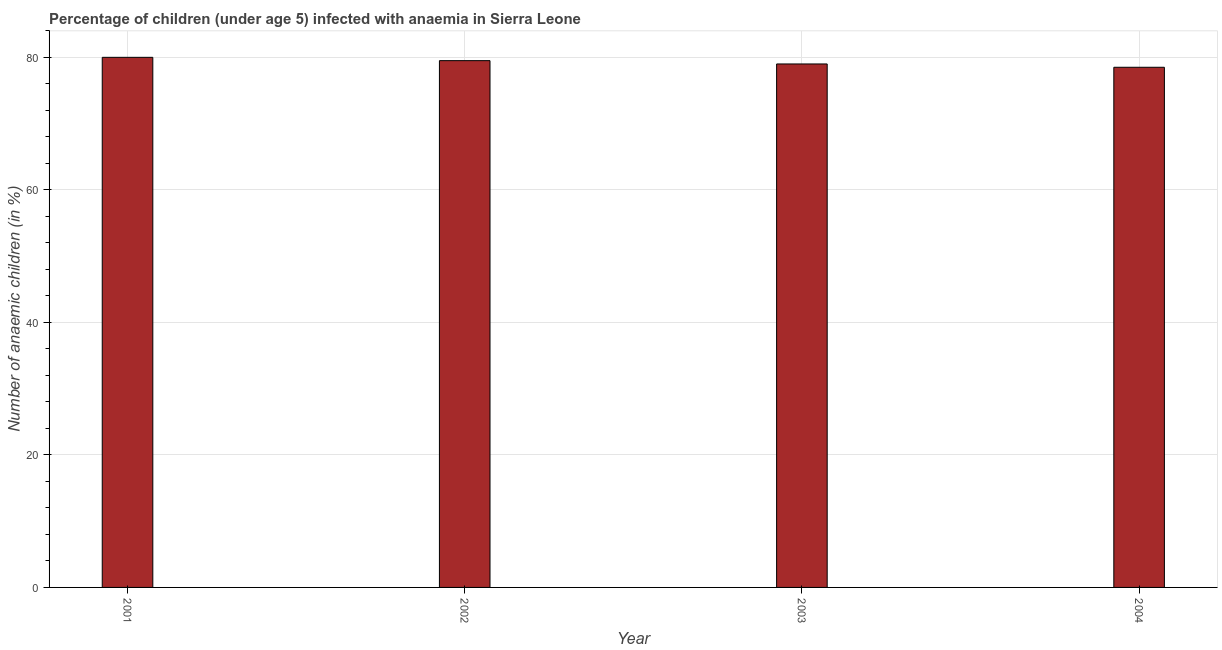What is the title of the graph?
Provide a short and direct response. Percentage of children (under age 5) infected with anaemia in Sierra Leone. What is the label or title of the Y-axis?
Make the answer very short. Number of anaemic children (in %). What is the number of anaemic children in 2002?
Your answer should be very brief. 79.5. Across all years, what is the minimum number of anaemic children?
Make the answer very short. 78.5. In which year was the number of anaemic children maximum?
Make the answer very short. 2001. In which year was the number of anaemic children minimum?
Ensure brevity in your answer.  2004. What is the sum of the number of anaemic children?
Offer a very short reply. 317. What is the average number of anaemic children per year?
Your response must be concise. 79.25. What is the median number of anaemic children?
Your response must be concise. 79.25. What is the ratio of the number of anaemic children in 2002 to that in 2003?
Your response must be concise. 1.01. Is the number of anaemic children in 2002 less than that in 2004?
Offer a terse response. No. What is the difference between the highest and the second highest number of anaemic children?
Give a very brief answer. 0.5. Is the sum of the number of anaemic children in 2001 and 2004 greater than the maximum number of anaemic children across all years?
Give a very brief answer. Yes. What is the difference between the highest and the lowest number of anaemic children?
Provide a succinct answer. 1.5. How many bars are there?
Offer a very short reply. 4. Are the values on the major ticks of Y-axis written in scientific E-notation?
Your answer should be very brief. No. What is the Number of anaemic children (in %) of 2002?
Make the answer very short. 79.5. What is the Number of anaemic children (in %) in 2003?
Offer a very short reply. 79. What is the Number of anaemic children (in %) in 2004?
Give a very brief answer. 78.5. What is the difference between the Number of anaemic children (in %) in 2001 and 2002?
Provide a succinct answer. 0.5. What is the difference between the Number of anaemic children (in %) in 2001 and 2003?
Ensure brevity in your answer.  1. What is the difference between the Number of anaemic children (in %) in 2001 and 2004?
Offer a very short reply. 1.5. What is the difference between the Number of anaemic children (in %) in 2002 and 2003?
Offer a terse response. 0.5. What is the difference between the Number of anaemic children (in %) in 2002 and 2004?
Make the answer very short. 1. What is the ratio of the Number of anaemic children (in %) in 2001 to that in 2003?
Give a very brief answer. 1.01. What is the ratio of the Number of anaemic children (in %) in 2002 to that in 2003?
Keep it short and to the point. 1.01. What is the ratio of the Number of anaemic children (in %) in 2003 to that in 2004?
Your response must be concise. 1.01. 